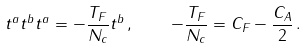Convert formula to latex. <formula><loc_0><loc_0><loc_500><loc_500>t ^ { a } t ^ { b } t ^ { a } = - \frac { T _ { F } } { N _ { c } } t ^ { b } \, , \quad - \frac { T _ { F } } { N _ { c } } = C _ { F } - \frac { C _ { A } } { 2 } \, .</formula> 